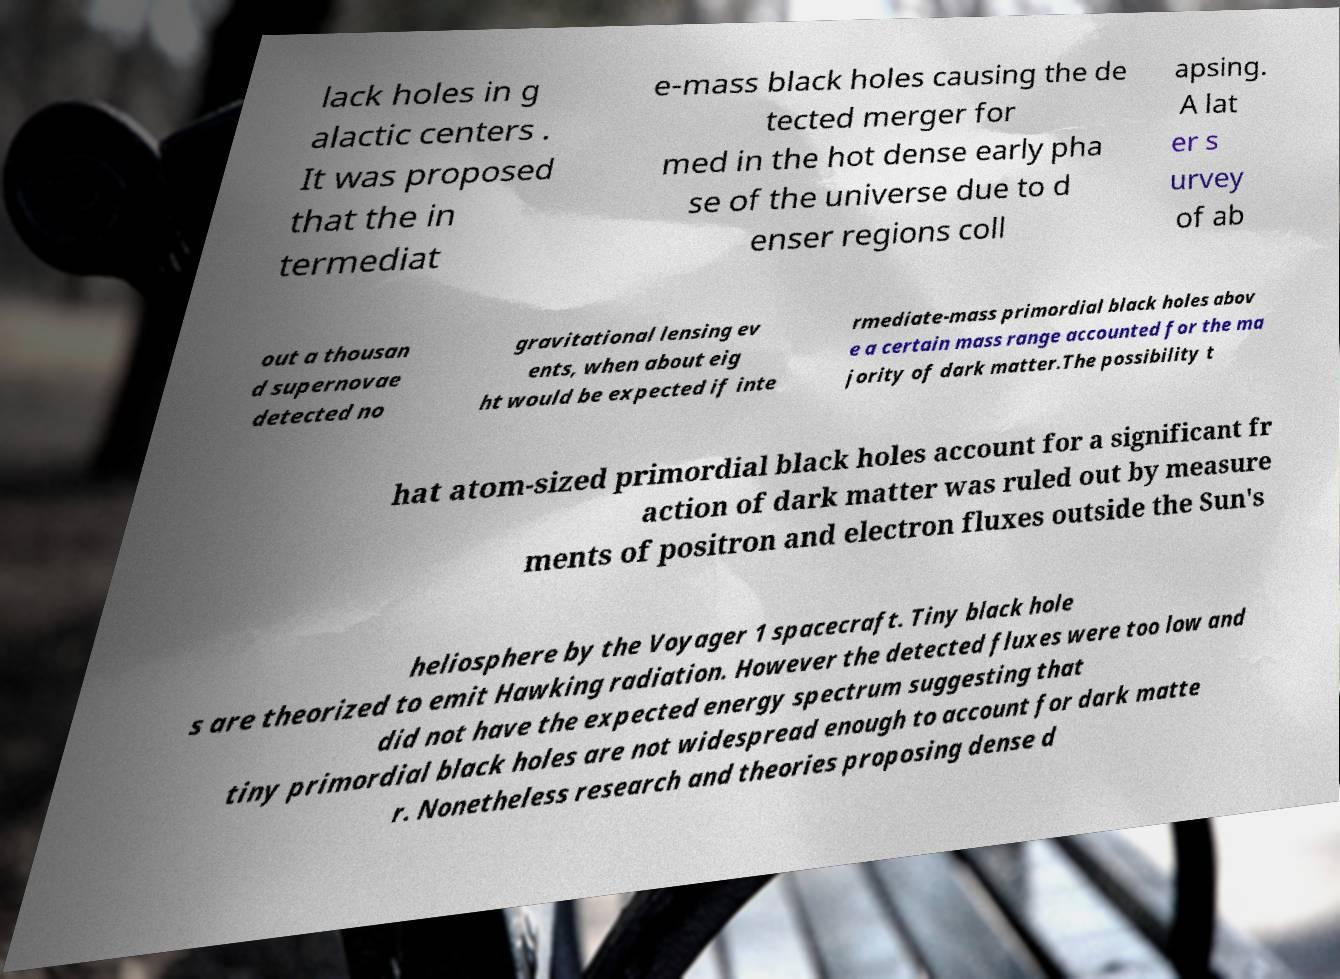I need the written content from this picture converted into text. Can you do that? lack holes in g alactic centers . It was proposed that the in termediat e-mass black holes causing the de tected merger for med in the hot dense early pha se of the universe due to d enser regions coll apsing. A lat er s urvey of ab out a thousan d supernovae detected no gravitational lensing ev ents, when about eig ht would be expected if inte rmediate-mass primordial black holes abov e a certain mass range accounted for the ma jority of dark matter.The possibility t hat atom-sized primordial black holes account for a significant fr action of dark matter was ruled out by measure ments of positron and electron fluxes outside the Sun's heliosphere by the Voyager 1 spacecraft. Tiny black hole s are theorized to emit Hawking radiation. However the detected fluxes were too low and did not have the expected energy spectrum suggesting that tiny primordial black holes are not widespread enough to account for dark matte r. Nonetheless research and theories proposing dense d 